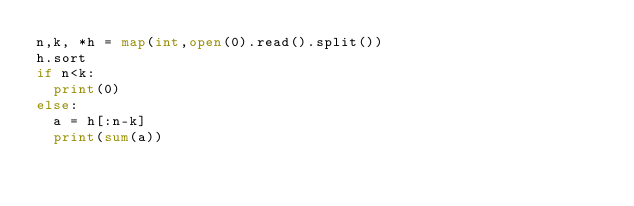<code> <loc_0><loc_0><loc_500><loc_500><_Python_>n,k, *h = map(int,open(0).read().split())
h.sort 
if n<k:
  print(0)
else:
  a = h[:n-k]
  print(sum(a))</code> 